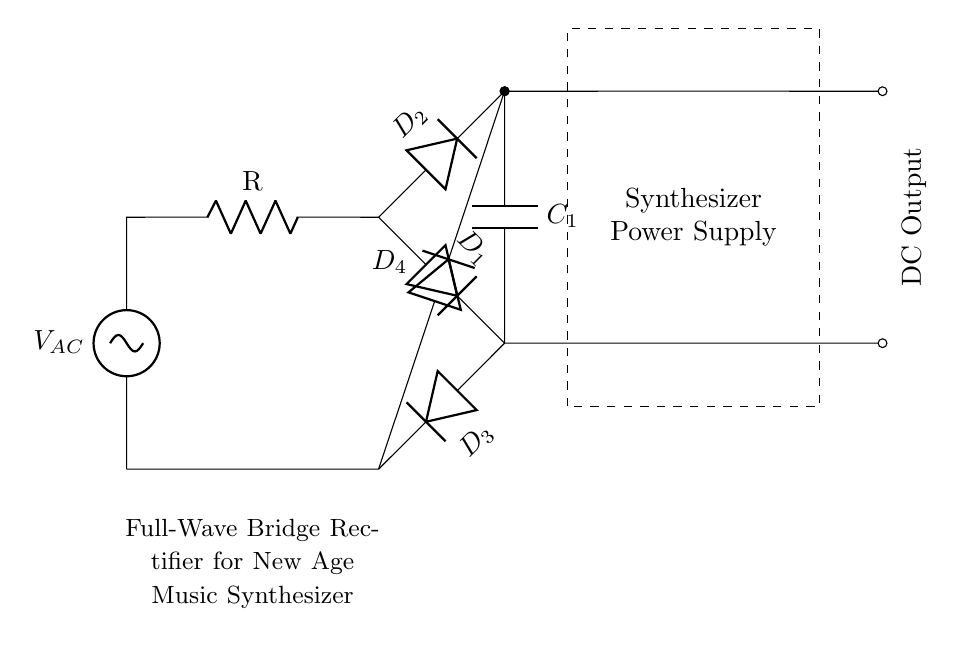What type of rectifier is shown in the circuit? The circuit is a full-wave bridge rectifier, characterized by four diodes arranged in a bridge configuration allowing both halves of the AC input waveform to be converted to DC output.
Answer: full-wave bridge rectifier How many diodes are in the circuit? There are four diodes in the circuit, labeled D1, D2, D3, and D4, forming the full-wave bridge rectifier arrangement.
Answer: four What is the function of the capacitor in this circuit? The capacitor, labeled C1, smooths the output voltage by charging during the peaks of the waveform and discharging during the troughs, thereby reducing voltage ripple and providing a more stable DC output.
Answer: smoothing What is the input voltage label in the circuit? The input voltage is labeled V_AC, indicating it is the alternating current voltage supplied to the rectifier.
Answer: V_AC Which components facilitate the conversion of AC to DC in this circuit? The four diodes (D1, D2, D3, and D4) facilitate the conversion by allowing current to flow in one direction during both halves of the AC cycle, thus generating a DC output.
Answer: diodes What is the purpose of the resistor in this circuit? The resistor labeled R is typically used to limit current flow, protect components, or set the load in the circuit, though its specific function would depend on the overall design.
Answer: current limiting What side of the circuit represents the DC output? The right side of the circuit, where the connections lead to the labeled DC Output, indicates the output of the rectified and smoothed signal.
Answer: right side 